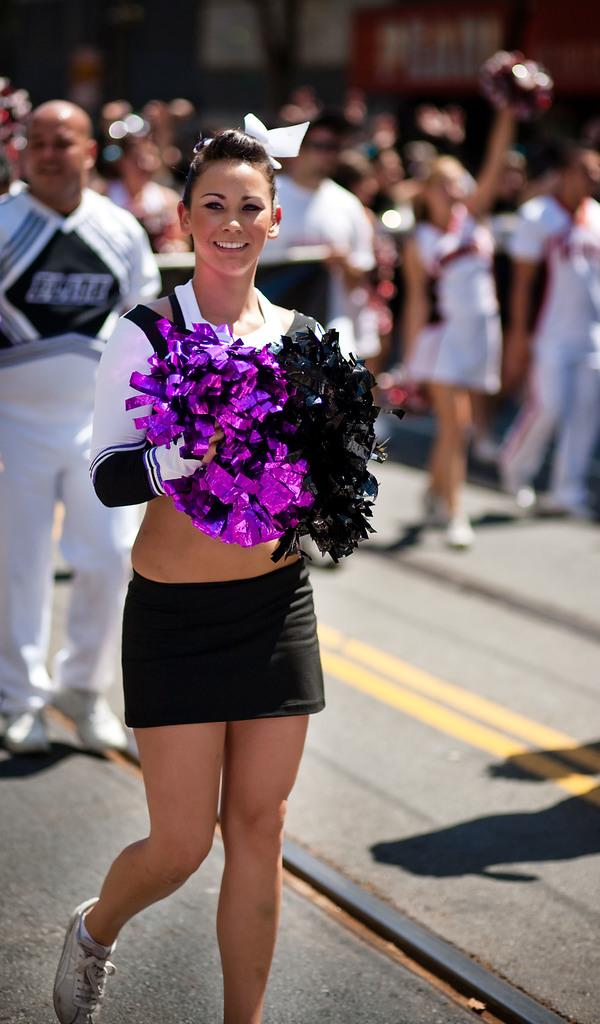Who is the main subject in the foreground of the image? There is a woman in the foreground of the image. What is the woman holding in the image? The woman is holding glitter flowers. Can you describe the background of the image? There are people in the background of the image. What type of harmony can be heard in the image? There is no audible sound or music in the image, so it is not possible to determine what type of harmony might be heard. 